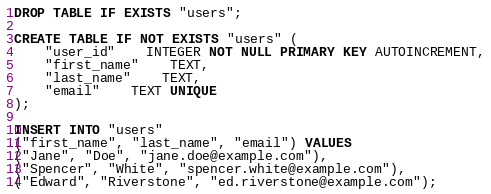Convert code to text. <code><loc_0><loc_0><loc_500><loc_500><_SQL_>DROP TABLE IF EXISTS "users";

CREATE TABLE IF NOT EXISTS "users" (
	"user_id"	INTEGER NOT NULL PRIMARY KEY AUTOINCREMENT,
	"first_name"	TEXT,
	"last_name"	TEXT,
	"email"	TEXT UNIQUE
);

INSERT INTO "users"
("first_name", "last_name", "email") VALUES
("Jane", "Doe", "jane.doe@example.com"),
("Spencer", "White", "spencer.white@example.com"),
("Edward", "Riverstone", "ed.riverstone@example.com");
</code> 